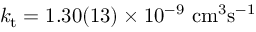Convert formula to latex. <formula><loc_0><loc_0><loc_500><loc_500>k _ { t } = 1 . 3 0 ( 1 3 ) \times 1 0 ^ { - 9 } c m ^ { 3 } s ^ { - 1 }</formula> 